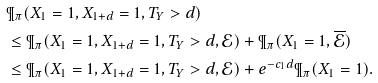Convert formula to latex. <formula><loc_0><loc_0><loc_500><loc_500>& \P _ { \pi } ( X _ { 1 } = 1 , X _ { 1 + d } = 1 , T _ { Y } > d ) \\ & \leq \P _ { \pi } ( X _ { 1 } = 1 , X _ { 1 + d } = 1 , T _ { Y } > d , \mathcal { E } ) + \P _ { \pi } ( X _ { 1 } = 1 , \overline { \mathcal { E } } ) \\ & \leq \P _ { \pi } ( X _ { 1 } = 1 , X _ { 1 + d } = 1 , T _ { Y } > d , \mathcal { E } ) + e ^ { - c _ { 1 } d } \P _ { \pi } ( X _ { 1 } = 1 ) .</formula> 